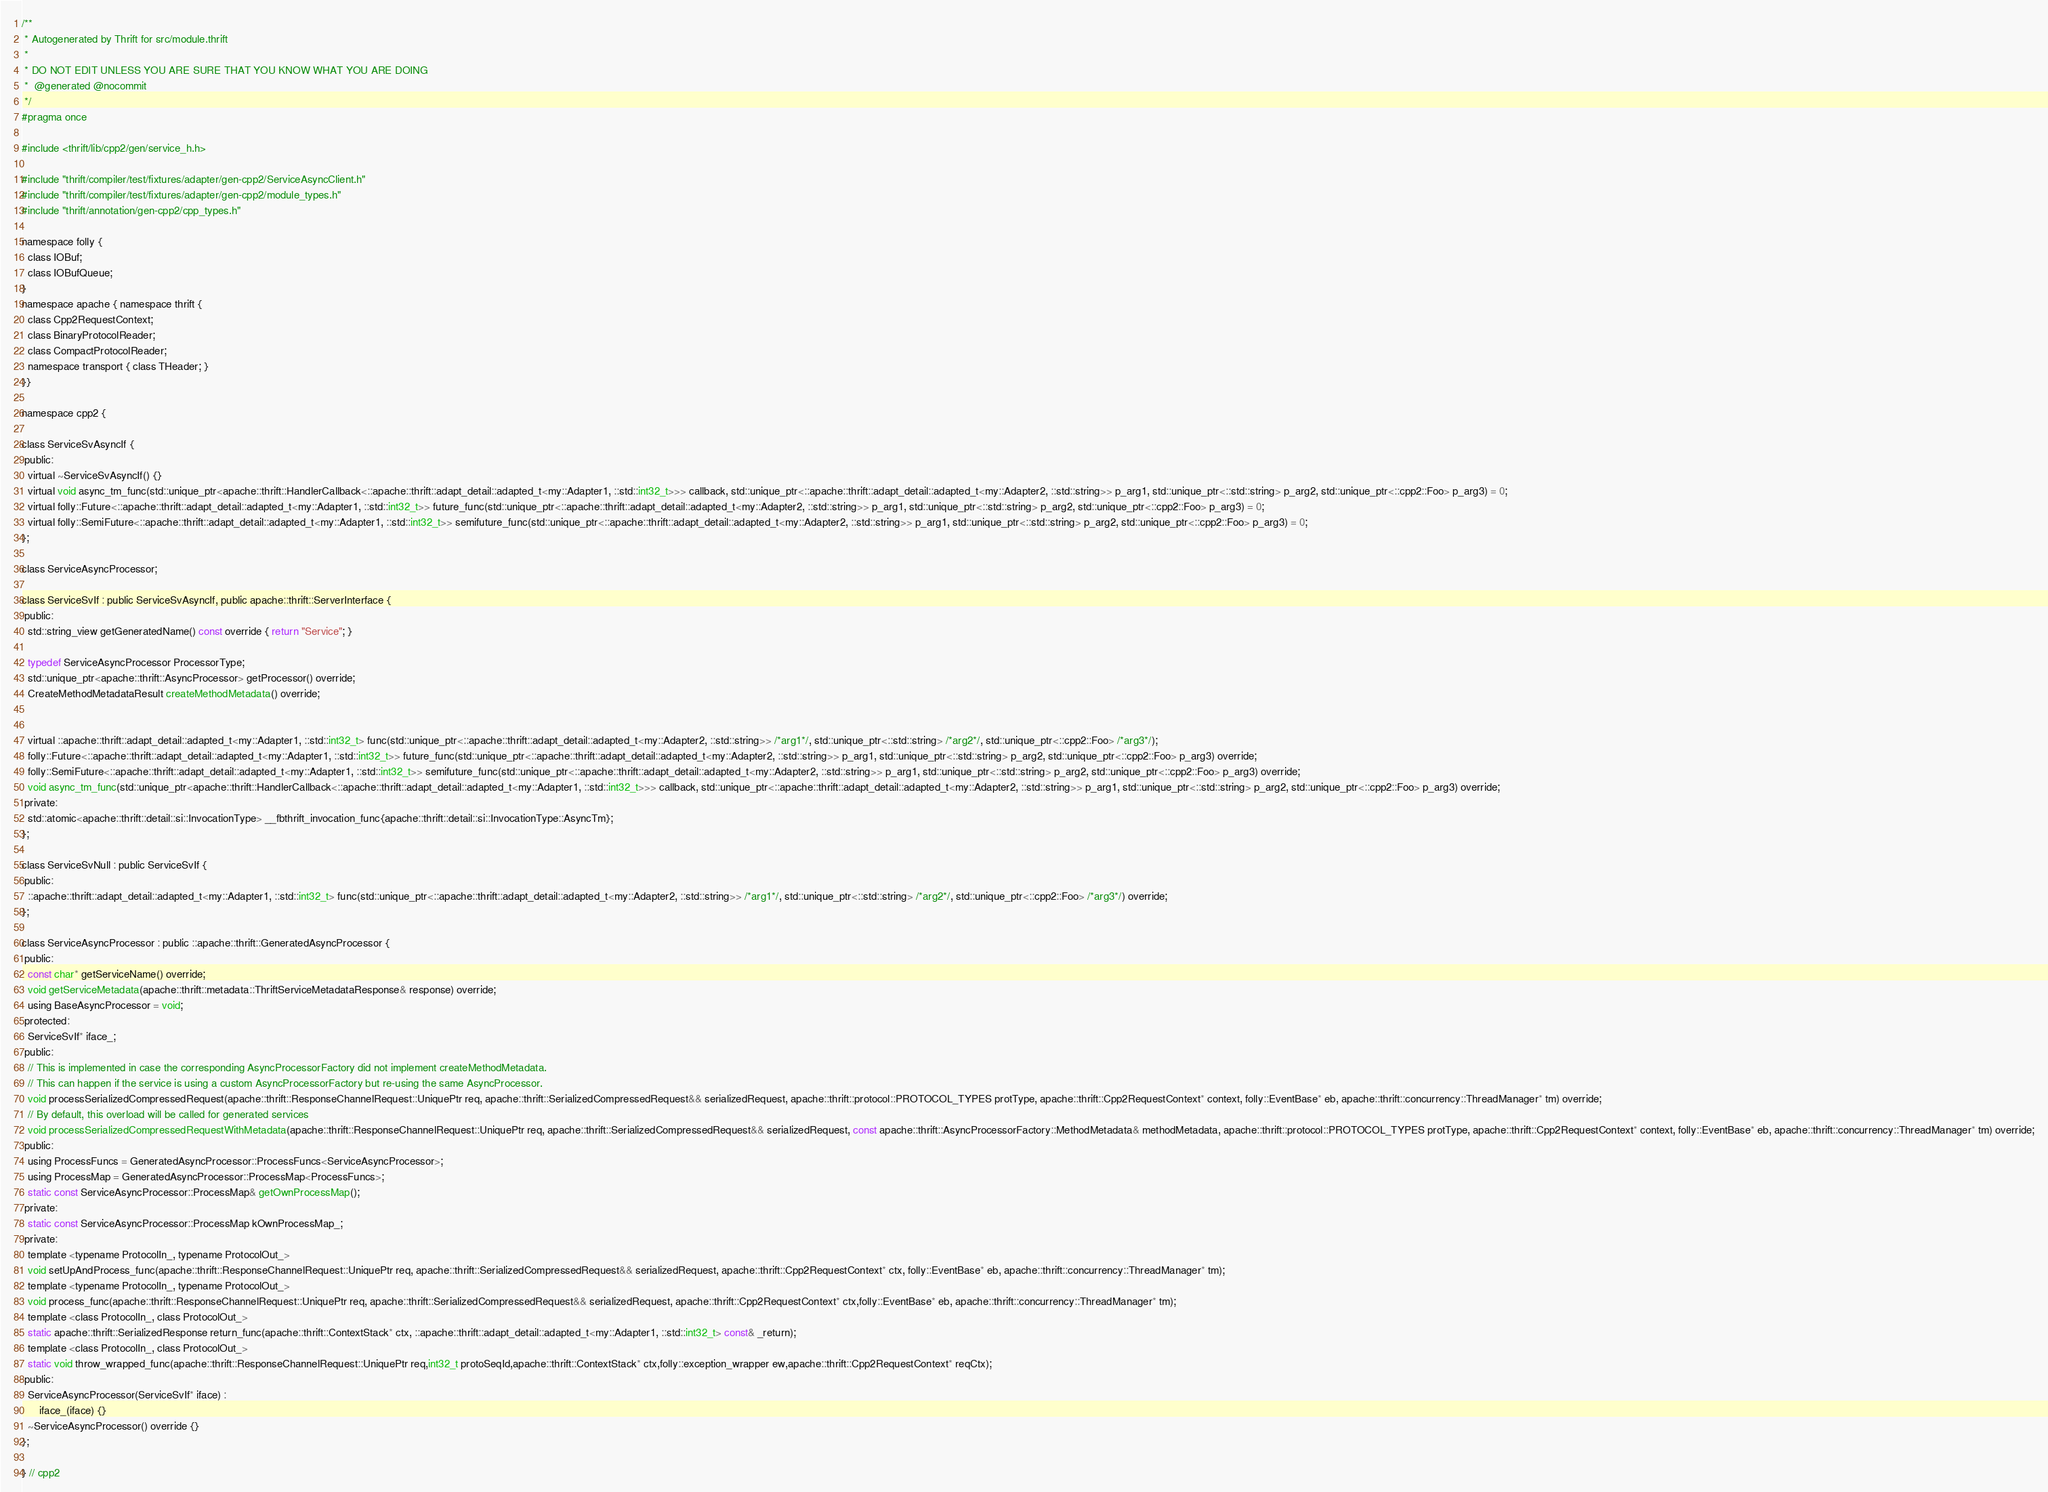<code> <loc_0><loc_0><loc_500><loc_500><_C_>/**
 * Autogenerated by Thrift for src/module.thrift
 *
 * DO NOT EDIT UNLESS YOU ARE SURE THAT YOU KNOW WHAT YOU ARE DOING
 *  @generated @nocommit
 */
#pragma once

#include <thrift/lib/cpp2/gen/service_h.h>

#include "thrift/compiler/test/fixtures/adapter/gen-cpp2/ServiceAsyncClient.h"
#include "thrift/compiler/test/fixtures/adapter/gen-cpp2/module_types.h"
#include "thrift/annotation/gen-cpp2/cpp_types.h"

namespace folly {
  class IOBuf;
  class IOBufQueue;
}
namespace apache { namespace thrift {
  class Cpp2RequestContext;
  class BinaryProtocolReader;
  class CompactProtocolReader;
  namespace transport { class THeader; }
}}

namespace cpp2 {

class ServiceSvAsyncIf {
 public:
  virtual ~ServiceSvAsyncIf() {}
  virtual void async_tm_func(std::unique_ptr<apache::thrift::HandlerCallback<::apache::thrift::adapt_detail::adapted_t<my::Adapter1, ::std::int32_t>>> callback, std::unique_ptr<::apache::thrift::adapt_detail::adapted_t<my::Adapter2, ::std::string>> p_arg1, std::unique_ptr<::std::string> p_arg2, std::unique_ptr<::cpp2::Foo> p_arg3) = 0;
  virtual folly::Future<::apache::thrift::adapt_detail::adapted_t<my::Adapter1, ::std::int32_t>> future_func(std::unique_ptr<::apache::thrift::adapt_detail::adapted_t<my::Adapter2, ::std::string>> p_arg1, std::unique_ptr<::std::string> p_arg2, std::unique_ptr<::cpp2::Foo> p_arg3) = 0;
  virtual folly::SemiFuture<::apache::thrift::adapt_detail::adapted_t<my::Adapter1, ::std::int32_t>> semifuture_func(std::unique_ptr<::apache::thrift::adapt_detail::adapted_t<my::Adapter2, ::std::string>> p_arg1, std::unique_ptr<::std::string> p_arg2, std::unique_ptr<::cpp2::Foo> p_arg3) = 0;
};

class ServiceAsyncProcessor;

class ServiceSvIf : public ServiceSvAsyncIf, public apache::thrift::ServerInterface {
 public:
  std::string_view getGeneratedName() const override { return "Service"; }

  typedef ServiceAsyncProcessor ProcessorType;
  std::unique_ptr<apache::thrift::AsyncProcessor> getProcessor() override;
  CreateMethodMetadataResult createMethodMetadata() override;


  virtual ::apache::thrift::adapt_detail::adapted_t<my::Adapter1, ::std::int32_t> func(std::unique_ptr<::apache::thrift::adapt_detail::adapted_t<my::Adapter2, ::std::string>> /*arg1*/, std::unique_ptr<::std::string> /*arg2*/, std::unique_ptr<::cpp2::Foo> /*arg3*/);
  folly::Future<::apache::thrift::adapt_detail::adapted_t<my::Adapter1, ::std::int32_t>> future_func(std::unique_ptr<::apache::thrift::adapt_detail::adapted_t<my::Adapter2, ::std::string>> p_arg1, std::unique_ptr<::std::string> p_arg2, std::unique_ptr<::cpp2::Foo> p_arg3) override;
  folly::SemiFuture<::apache::thrift::adapt_detail::adapted_t<my::Adapter1, ::std::int32_t>> semifuture_func(std::unique_ptr<::apache::thrift::adapt_detail::adapted_t<my::Adapter2, ::std::string>> p_arg1, std::unique_ptr<::std::string> p_arg2, std::unique_ptr<::cpp2::Foo> p_arg3) override;
  void async_tm_func(std::unique_ptr<apache::thrift::HandlerCallback<::apache::thrift::adapt_detail::adapted_t<my::Adapter1, ::std::int32_t>>> callback, std::unique_ptr<::apache::thrift::adapt_detail::adapted_t<my::Adapter2, ::std::string>> p_arg1, std::unique_ptr<::std::string> p_arg2, std::unique_ptr<::cpp2::Foo> p_arg3) override;
 private:
  std::atomic<apache::thrift::detail::si::InvocationType> __fbthrift_invocation_func{apache::thrift::detail::si::InvocationType::AsyncTm};
};

class ServiceSvNull : public ServiceSvIf {
 public:
  ::apache::thrift::adapt_detail::adapted_t<my::Adapter1, ::std::int32_t> func(std::unique_ptr<::apache::thrift::adapt_detail::adapted_t<my::Adapter2, ::std::string>> /*arg1*/, std::unique_ptr<::std::string> /*arg2*/, std::unique_ptr<::cpp2::Foo> /*arg3*/) override;
};

class ServiceAsyncProcessor : public ::apache::thrift::GeneratedAsyncProcessor {
 public:
  const char* getServiceName() override;
  void getServiceMetadata(apache::thrift::metadata::ThriftServiceMetadataResponse& response) override;
  using BaseAsyncProcessor = void;
 protected:
  ServiceSvIf* iface_;
 public:
  // This is implemented in case the corresponding AsyncProcessorFactory did not implement createMethodMetadata.
  // This can happen if the service is using a custom AsyncProcessorFactory but re-using the same AsyncProcessor.
  void processSerializedCompressedRequest(apache::thrift::ResponseChannelRequest::UniquePtr req, apache::thrift::SerializedCompressedRequest&& serializedRequest, apache::thrift::protocol::PROTOCOL_TYPES protType, apache::thrift::Cpp2RequestContext* context, folly::EventBase* eb, apache::thrift::concurrency::ThreadManager* tm) override;
  // By default, this overload will be called for generated services
  void processSerializedCompressedRequestWithMetadata(apache::thrift::ResponseChannelRequest::UniquePtr req, apache::thrift::SerializedCompressedRequest&& serializedRequest, const apache::thrift::AsyncProcessorFactory::MethodMetadata& methodMetadata, apache::thrift::protocol::PROTOCOL_TYPES protType, apache::thrift::Cpp2RequestContext* context, folly::EventBase* eb, apache::thrift::concurrency::ThreadManager* tm) override;
 public:
  using ProcessFuncs = GeneratedAsyncProcessor::ProcessFuncs<ServiceAsyncProcessor>;
  using ProcessMap = GeneratedAsyncProcessor::ProcessMap<ProcessFuncs>;
  static const ServiceAsyncProcessor::ProcessMap& getOwnProcessMap();
 private:
  static const ServiceAsyncProcessor::ProcessMap kOwnProcessMap_;
 private:
  template <typename ProtocolIn_, typename ProtocolOut_>
  void setUpAndProcess_func(apache::thrift::ResponseChannelRequest::UniquePtr req, apache::thrift::SerializedCompressedRequest&& serializedRequest, apache::thrift::Cpp2RequestContext* ctx, folly::EventBase* eb, apache::thrift::concurrency::ThreadManager* tm);
  template <typename ProtocolIn_, typename ProtocolOut_>
  void process_func(apache::thrift::ResponseChannelRequest::UniquePtr req, apache::thrift::SerializedCompressedRequest&& serializedRequest, apache::thrift::Cpp2RequestContext* ctx,folly::EventBase* eb, apache::thrift::concurrency::ThreadManager* tm);
  template <class ProtocolIn_, class ProtocolOut_>
  static apache::thrift::SerializedResponse return_func(apache::thrift::ContextStack* ctx, ::apache::thrift::adapt_detail::adapted_t<my::Adapter1, ::std::int32_t> const& _return);
  template <class ProtocolIn_, class ProtocolOut_>
  static void throw_wrapped_func(apache::thrift::ResponseChannelRequest::UniquePtr req,int32_t protoSeqId,apache::thrift::ContextStack* ctx,folly::exception_wrapper ew,apache::thrift::Cpp2RequestContext* reqCtx);
 public:
  ServiceAsyncProcessor(ServiceSvIf* iface) :
      iface_(iface) {}
  ~ServiceAsyncProcessor() override {}
};

} // cpp2
</code> 